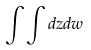Convert formula to latex. <formula><loc_0><loc_0><loc_500><loc_500>\int \int d z d w</formula> 